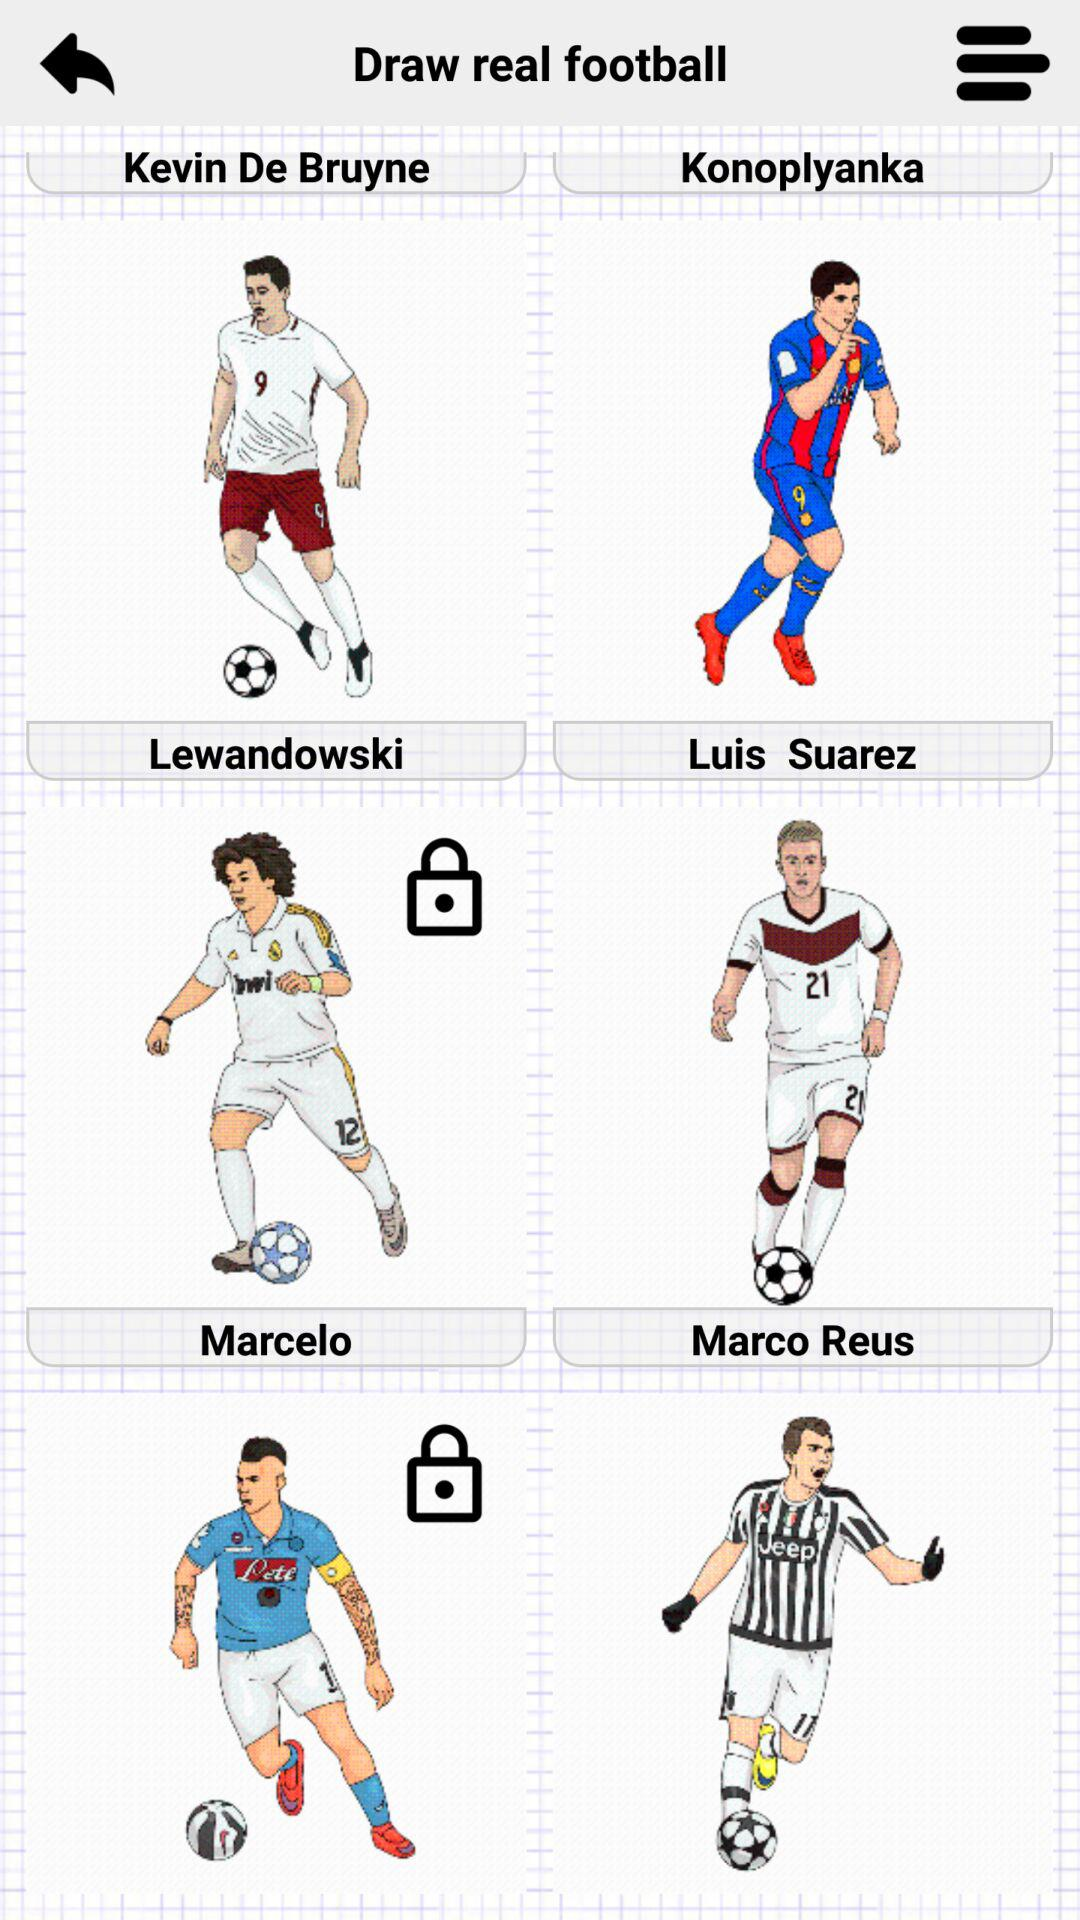What is the application name?
When the provided information is insufficient, respond with <no answer>. <no answer> 